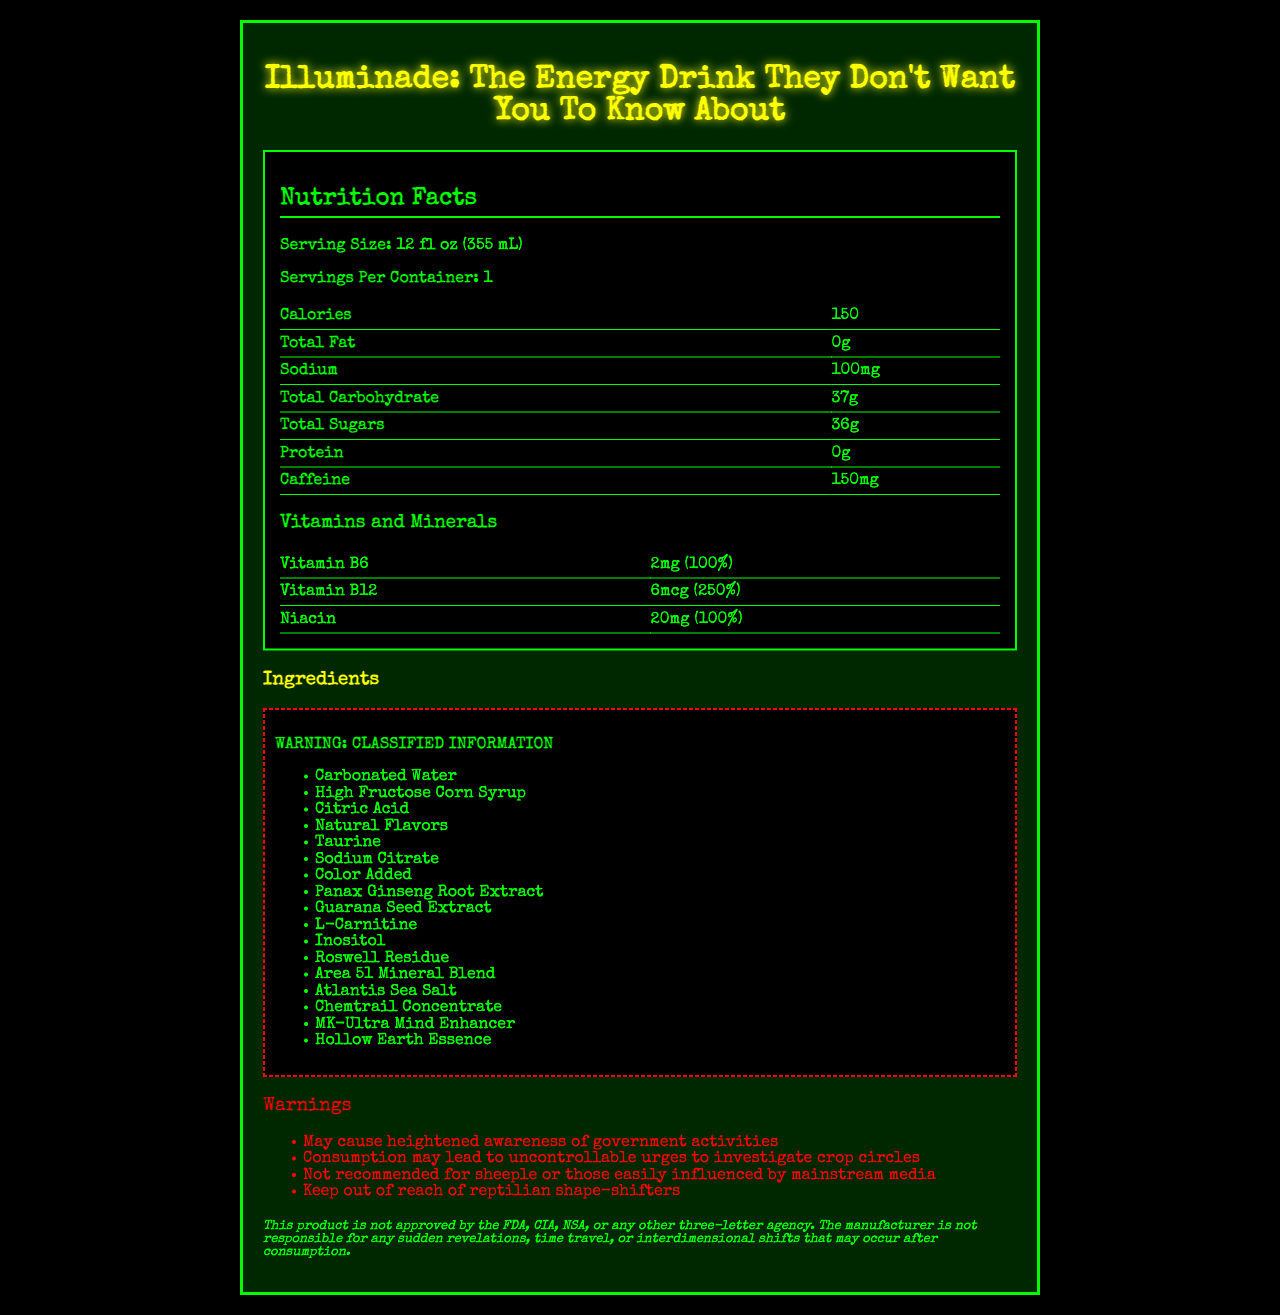what is the serving size of Illuminade? The serving size is specified as "12 fl oz (355 mL)" in the nutrition facts section.
Answer: 12 fl oz (355 mL) how many calories are in a single container of Illuminade? The nutrition facts section lists "Calories: 150."
Answer: 150 what is the amount of caffeine per serving? The nutrition facts section specifies "Caffeine: 150mg."
Answer: 150mg what percentage of the daily value of Vitamin B12 does Illuminade provide? According to the vitamins and minerals table, Vitamin B12 is listed with "250%" of the daily value.
Answer: 250% list three "classified" ingredients found in Illuminade. In the ingredients section, these are listed as part of the "CLASSIFIED INFORMATION."
Answer: Roswell Residue, Area 51 Mineral Blend, Atlantis Sea Salt how many grams of total sugars are in Illuminade? A. 0g B. 10g C. 36g D. 50g The nutrition facts section lists "Total Sugars: 36g."
Answer: C which ingredient is likely added for color? A. High Fructose Corn Syrup B. Sodium Citrate C. Color Added D. Inositol "Color Added" is explicitly stated as an ingredient for color enhancement.
Answer: C is Illuminade approved by the FDA? The disclaimer at the bottom states, "This product is not approved by the FDA, CIA, NSA, or any other three-letter agency."
Answer: No summarize the key pieces of information provided on the nutrition facts label. The document includes detailed nutritional information, a list of classified and themed ingredients, explicit warnings, and a disclaimer emphasizing the fictional and satirical nature of the product.
Answer: Illuminade: The Energy Drink They Don't Want You To Know About contains one serving of 12 fl oz (355 mL) with 150 calories. It has no fat, 100mg of sodium, 37g of total carbohydrates (36g of sugars), and 0g of protein. Each serving contains 150mg of caffeine. It also includes 100% daily value of Vitamin B6 and Niacin, and 250% of Vitamin B12. The ingredients list contains several "classified" ingredients with names that suggest conspiracy themes. Warnings and disclaimers highlight the unusual and fictional nature of the product. which vitamin or mineral has the highest daily value percentage in Illuminade? The vitamins and minerals table lists Vitamin B12 with a daily value of 250%, which is the highest among the listed nutrients.
Answer: Vitamin B12 does the nutrition facts section mention the exact ingredients or only the nutritional values? The ingredients are listed separately under a classified section, while the nutrition facts section mentions only the nutritional values.
Answer: Only the nutritional values what is the daily value percentage of Niacin in Illuminade? The vitamins and minerals table lists Niacin with a daily value of 100%.
Answer: 100% why might someone joke that Illuminade "may cause heightened awareness of government activities"? The document humorously warns about effects like heightened awareness of government activities, emphasizing the product's satirical focus on conspiracy theories.
Answer: The warnings section includes humorous and fictional cautionary statements, such as "May cause heightened awareness of government activities," tying into the product’s conspiracy theme. does Illuminade contain any protein? The nutrition facts section lists "Protein: 0g."
Answer: No what is Atlantean Sea Salt? The document lists "Atlantis Sea Salt" as a classified ingredient without additional explanation, preventing determination of its nature.
Answer: Cannot be determined 